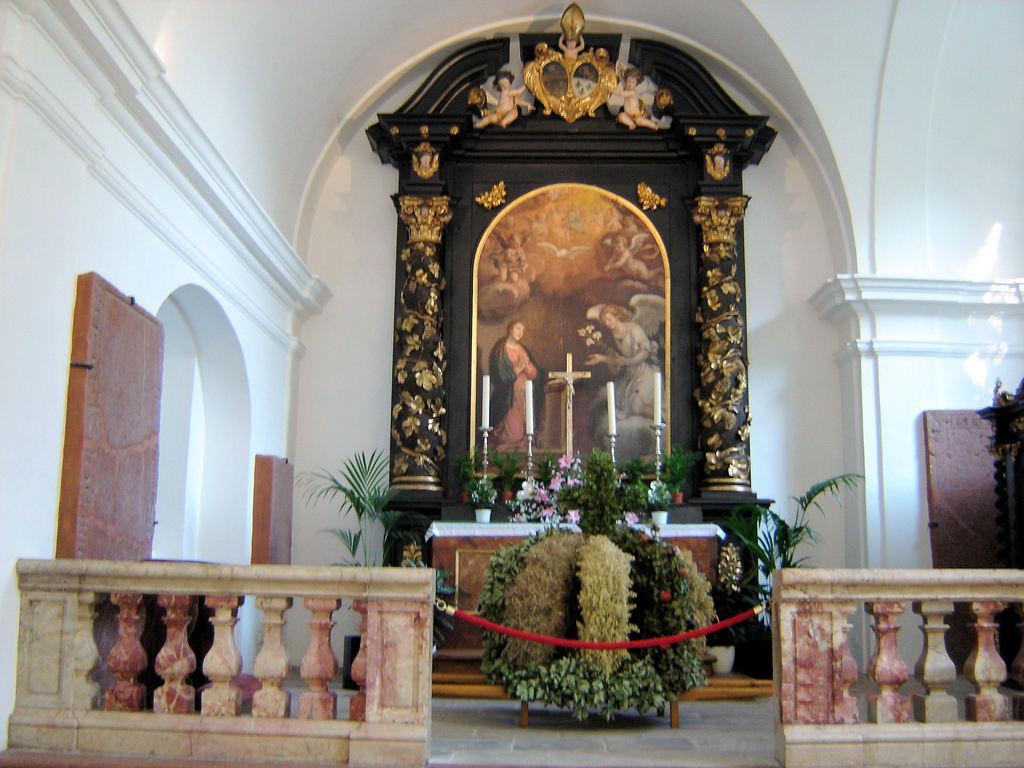Could you give a brief overview of what you see in this image? This is the inside picture of the church. At the center of the image there is a wall and a poster. There are candles, flower pots, plants. In front of the image there are cement railings. At the bottom of the image there is a floor. 